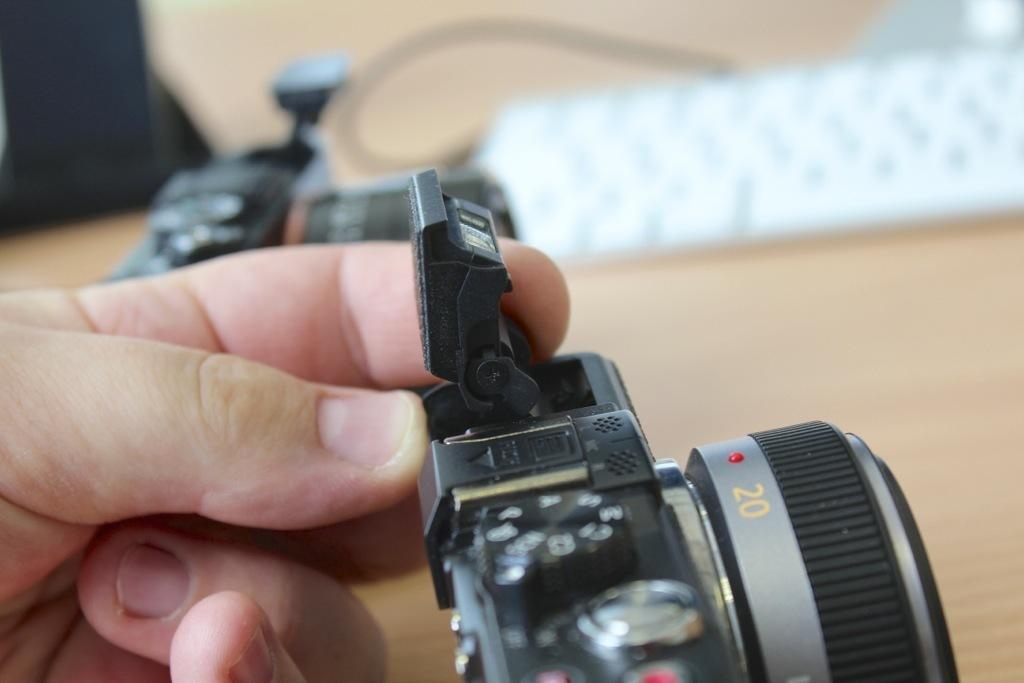What part of a person is visible in the image? There is a hand of a person in the image. What object is in front of the hand? There is a camera in front of the hand. What object is behind the hand? There is another camera behind the hand. How would you describe the background of the image? The background of the image is blurred. How many visitors can be seen in the image? There are no visitors present in the image; it only shows a hand and two cameras. What type of knot is being tied by the hand in the image? There is no knot-tying activity depicted in the image; it only shows a hand and two cameras. 